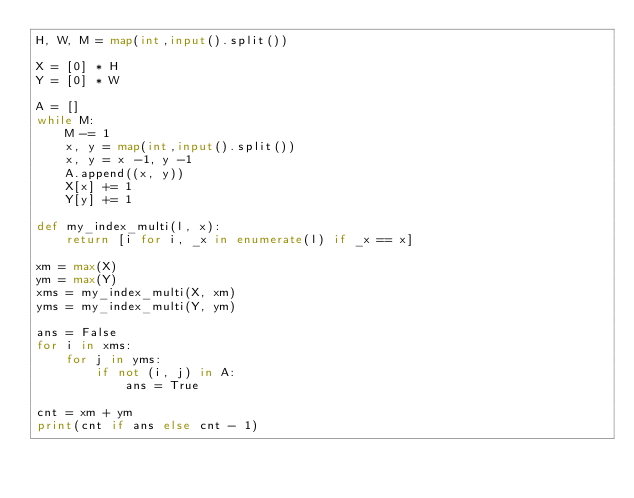<code> <loc_0><loc_0><loc_500><loc_500><_Python_>H, W, M = map(int,input().split())

X = [0] * H
Y = [0] * W

A = []
while M:
    M -= 1
    x, y = map(int,input().split())
    x, y = x -1, y -1
    A.append((x, y))
    X[x] += 1
    Y[y] += 1

def my_index_multi(l, x):
    return [i for i, _x in enumerate(l) if _x == x]

xm = max(X)
ym = max(Y)
xms = my_index_multi(X, xm)
yms = my_index_multi(Y, ym)

ans = False
for i in xms:
    for j in yms:
        if not (i, j) in A:
            ans = True
  
cnt = xm + ym         
print(cnt if ans else cnt - 1)</code> 